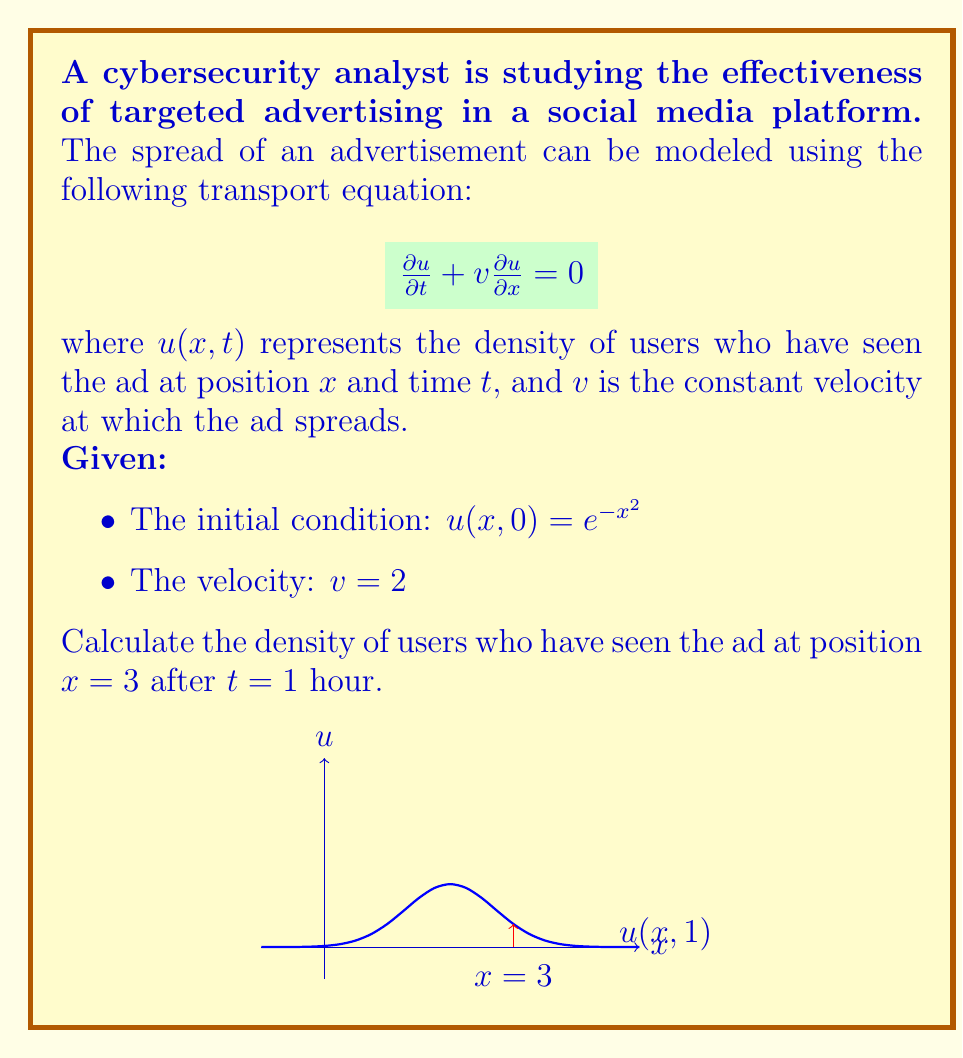Solve this math problem. Let's solve this problem step by step:

1) The general solution to the transport equation $\frac{\partial u}{\partial t} + v\frac{\partial u}{\partial x} = 0$ is:

   $u(x,t) = f(x - vt)$

   where $f$ is determined by the initial condition.

2) From the initial condition, we know that $f(x) = e^{-x^2}$.

3) Substituting this into our general solution:

   $u(x,t) = e^{-(x-vt)^2}$

4) We're given that $v = 2$, so:

   $u(x,t) = e^{-(x-2t)^2}$

5) We want to find $u(3,1)$, so let's substitute $x = 3$ and $t = 1$:

   $u(3,1) = e^{-(3-2(1))^2}$
            $= e^{-(3-2)^2}$
            $= e^{-1^2}$
            $= e^{-1}$

6) Therefore, the density of users who have seen the ad at $x = 3$ after $t = 1$ hour is $e^{-1}$.
Answer: $e^{-1}$ 